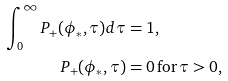Convert formula to latex. <formula><loc_0><loc_0><loc_500><loc_500>\int _ { 0 } ^ { \infty } P _ { + } ( \phi _ { * } , \tau ) d \tau & = 1 , \\ P _ { + } ( \phi _ { * } , \tau ) & = 0 \, \text {for} \, \tau > 0 ,</formula> 